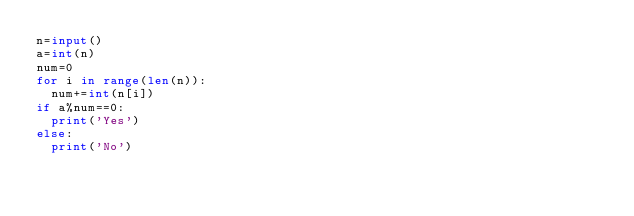Convert code to text. <code><loc_0><loc_0><loc_500><loc_500><_Python_>n=input()
a=int(n)
num=0
for i in range(len(n)):
  num+=int(n[i])
if a%num==0:
  print('Yes')
else:
  print('No')</code> 